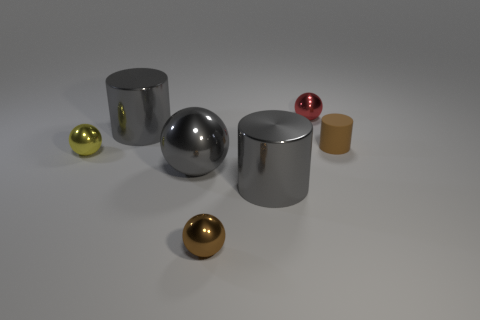Add 1 small red metal balls. How many objects exist? 8 Subtract all balls. How many objects are left? 3 Subtract 0 red blocks. How many objects are left? 7 Subtract all gray matte cylinders. Subtract all red metallic balls. How many objects are left? 6 Add 6 red metal balls. How many red metal balls are left? 7 Add 2 gray metallic things. How many gray metallic things exist? 5 